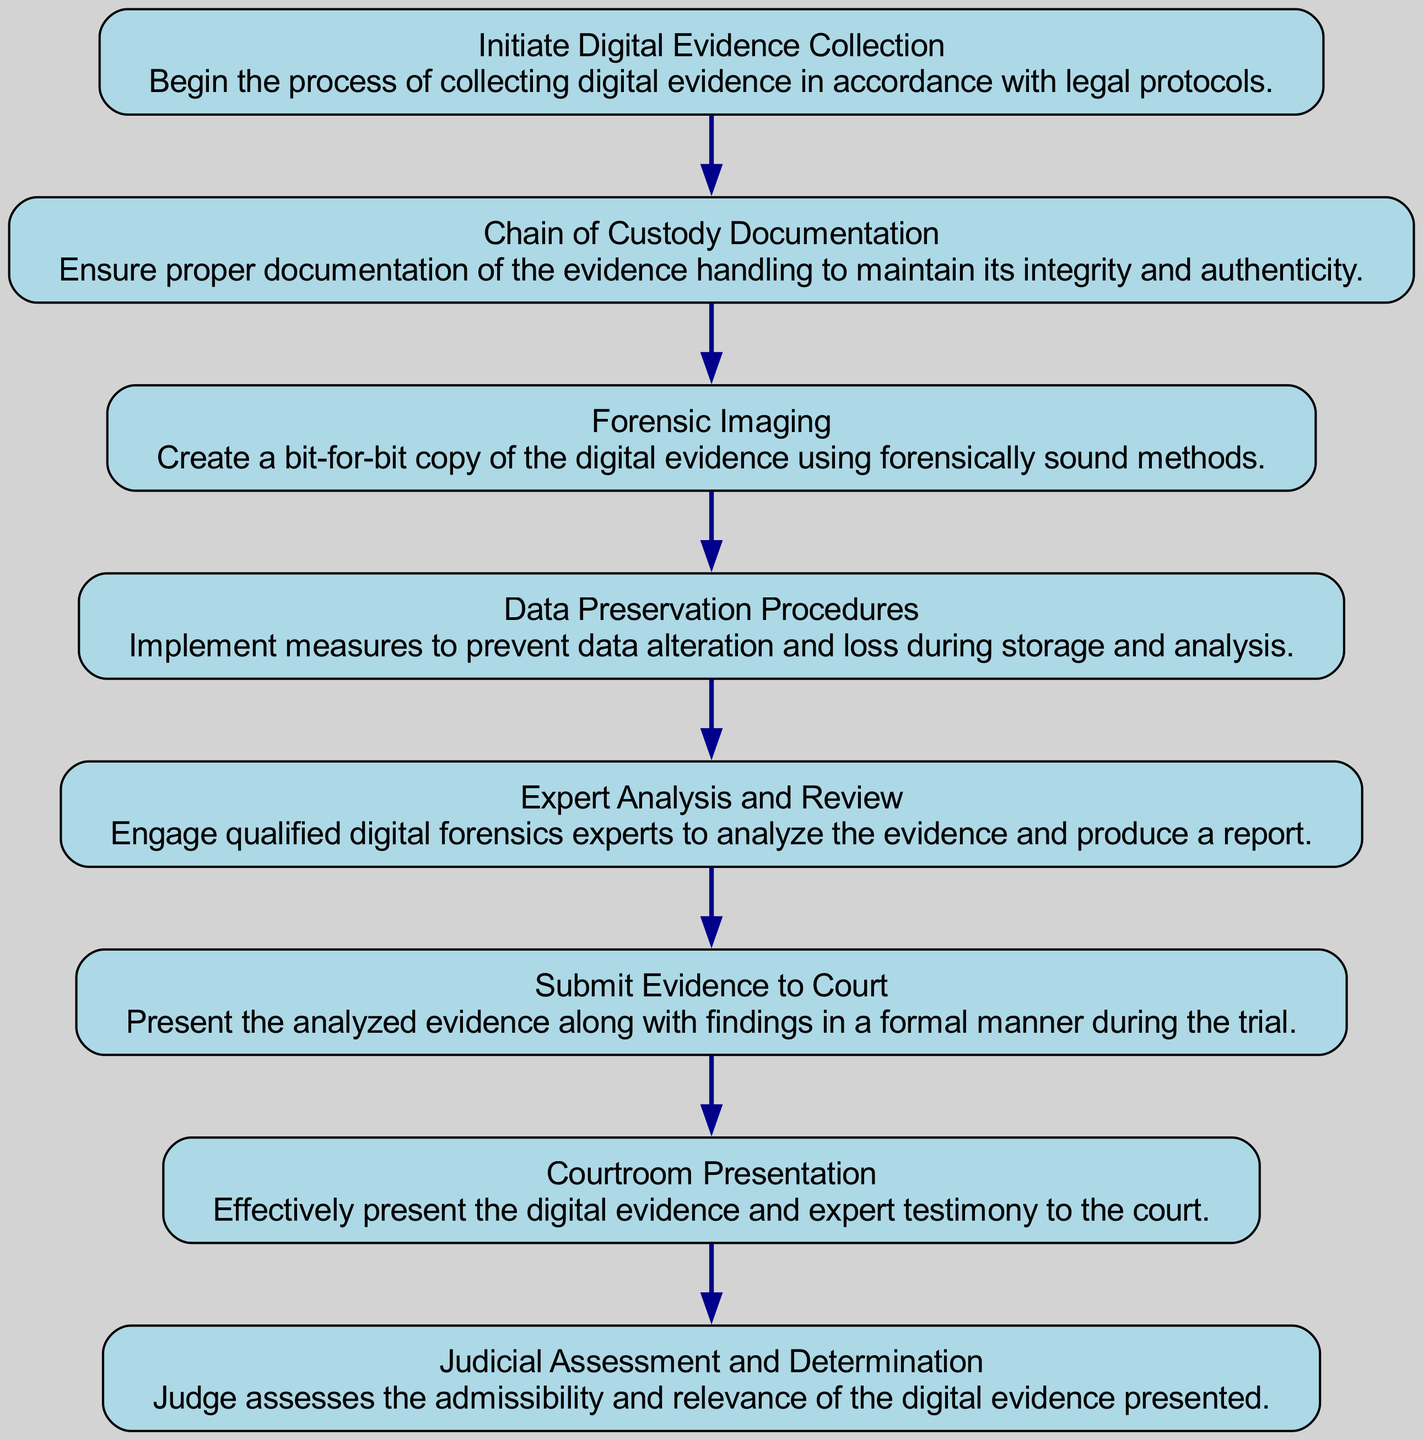What is the first step in the procedure? The first node in the flow chart is labeled "Initiate Digital Evidence Collection," indicating that this is where the procedure begins.
Answer: Initiate Digital Evidence Collection How many nodes are in the diagram? Counting each distinct step from start to finish, there are eight nodes representing various stages of the procedure.
Answer: 8 What follows "Chain of Custody Documentation"? The flow chart shows an arrow indicating that following "Chain of Custody Documentation," the next step is "Forensic Imaging."
Answer: Forensic Imaging Which step involves qualified experts? The node labeled "Expert Analysis and Review" clearly specifies the involvement of qualified digital forensics experts in analyzing the evidence.
Answer: Expert Analysis and Review What is the last step in the assessment process? According to the flow chart, the last node indicates "Judicial Assessment and Determination," which signifies the final evaluation by the judge.
Answer: Judicial Assessment and Determination What is the connection between "Data Preservation Procedures" and "Submit Evidence to Court"? The flow chart indicates a sequential flow where after "Data Preservation Procedures," the next step is "Submit Evidence to Court," showing the direct relationship in the process.
Answer: Submit Evidence to Court How many edges are between the nodes? Each node is connected to the next one, which results in a total of seven directed edges between the eight nodes in the flow chart.
Answer: 7 What does the "Courtroom Presentation" step signify? This step emphasizes the importance of effectively presenting both the digital evidence and the expert's testimony to the court during the trial.
Answer: Courtroom Presentation 